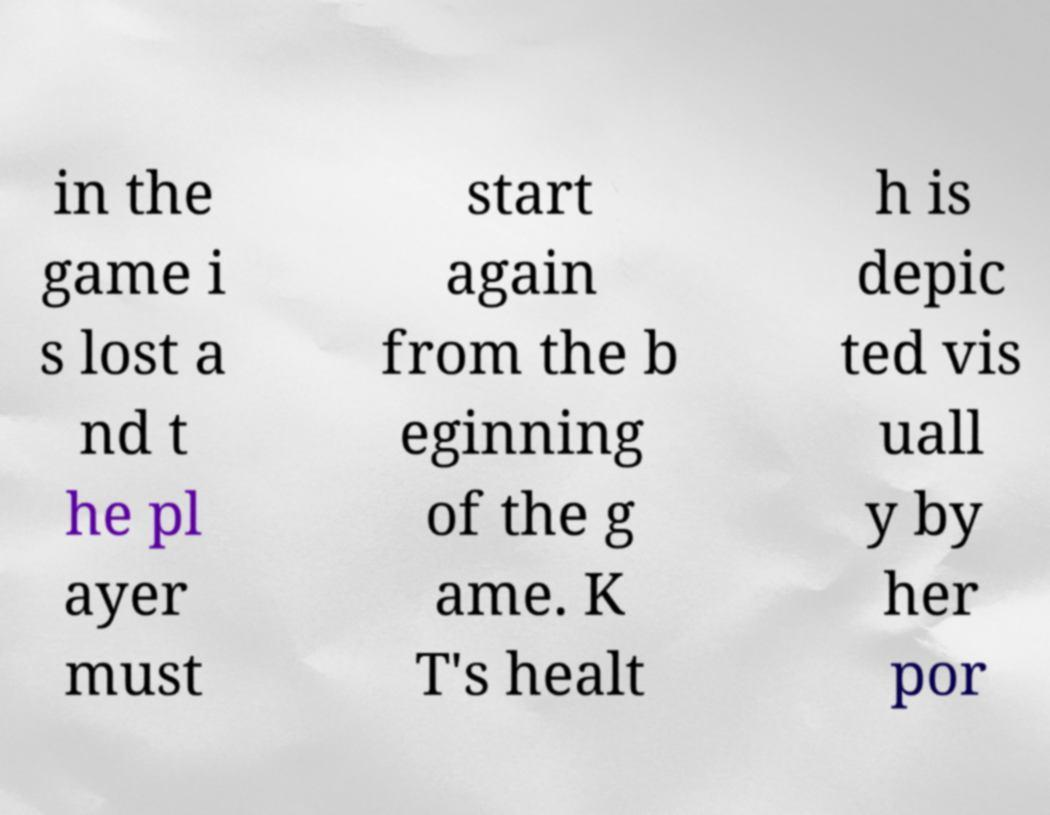There's text embedded in this image that I need extracted. Can you transcribe it verbatim? in the game i s lost a nd t he pl ayer must start again from the b eginning of the g ame. K T's healt h is depic ted vis uall y by her por 